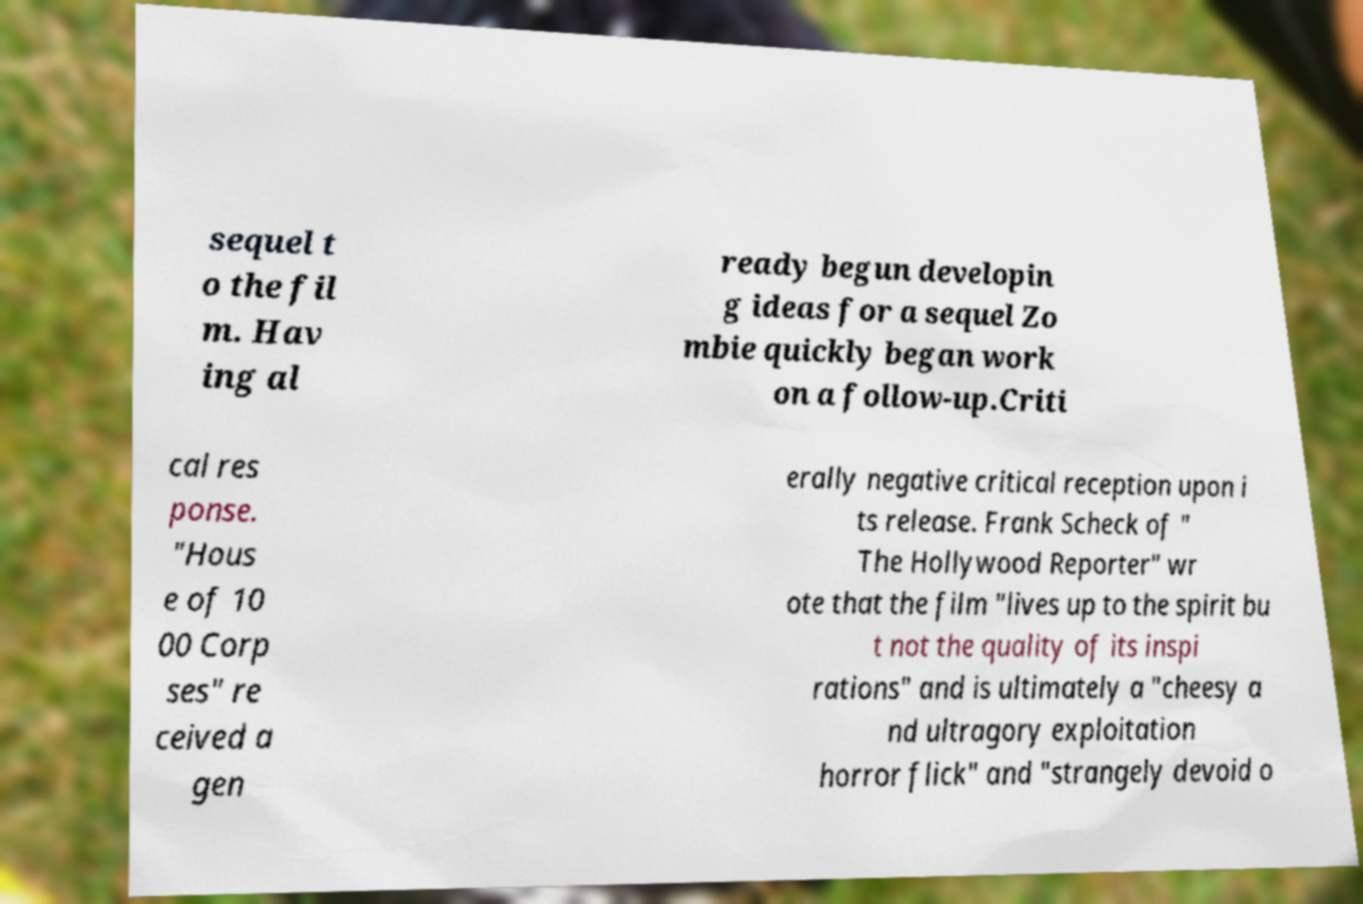Can you accurately transcribe the text from the provided image for me? sequel t o the fil m. Hav ing al ready begun developin g ideas for a sequel Zo mbie quickly began work on a follow-up.Criti cal res ponse. "Hous e of 10 00 Corp ses" re ceived a gen erally negative critical reception upon i ts release. Frank Scheck of " The Hollywood Reporter" wr ote that the film "lives up to the spirit bu t not the quality of its inspi rations" and is ultimately a "cheesy a nd ultragory exploitation horror flick" and "strangely devoid o 